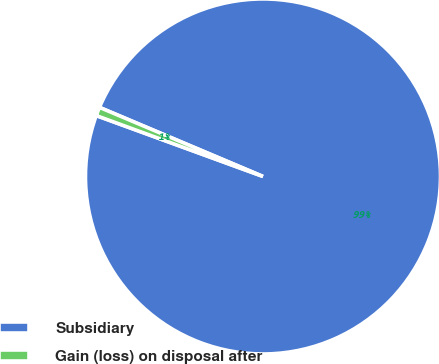Convert chart to OTSL. <chart><loc_0><loc_0><loc_500><loc_500><pie_chart><fcel>Subsidiary<fcel>Gain (loss) on disposal after<nl><fcel>99.21%<fcel>0.79%<nl></chart> 